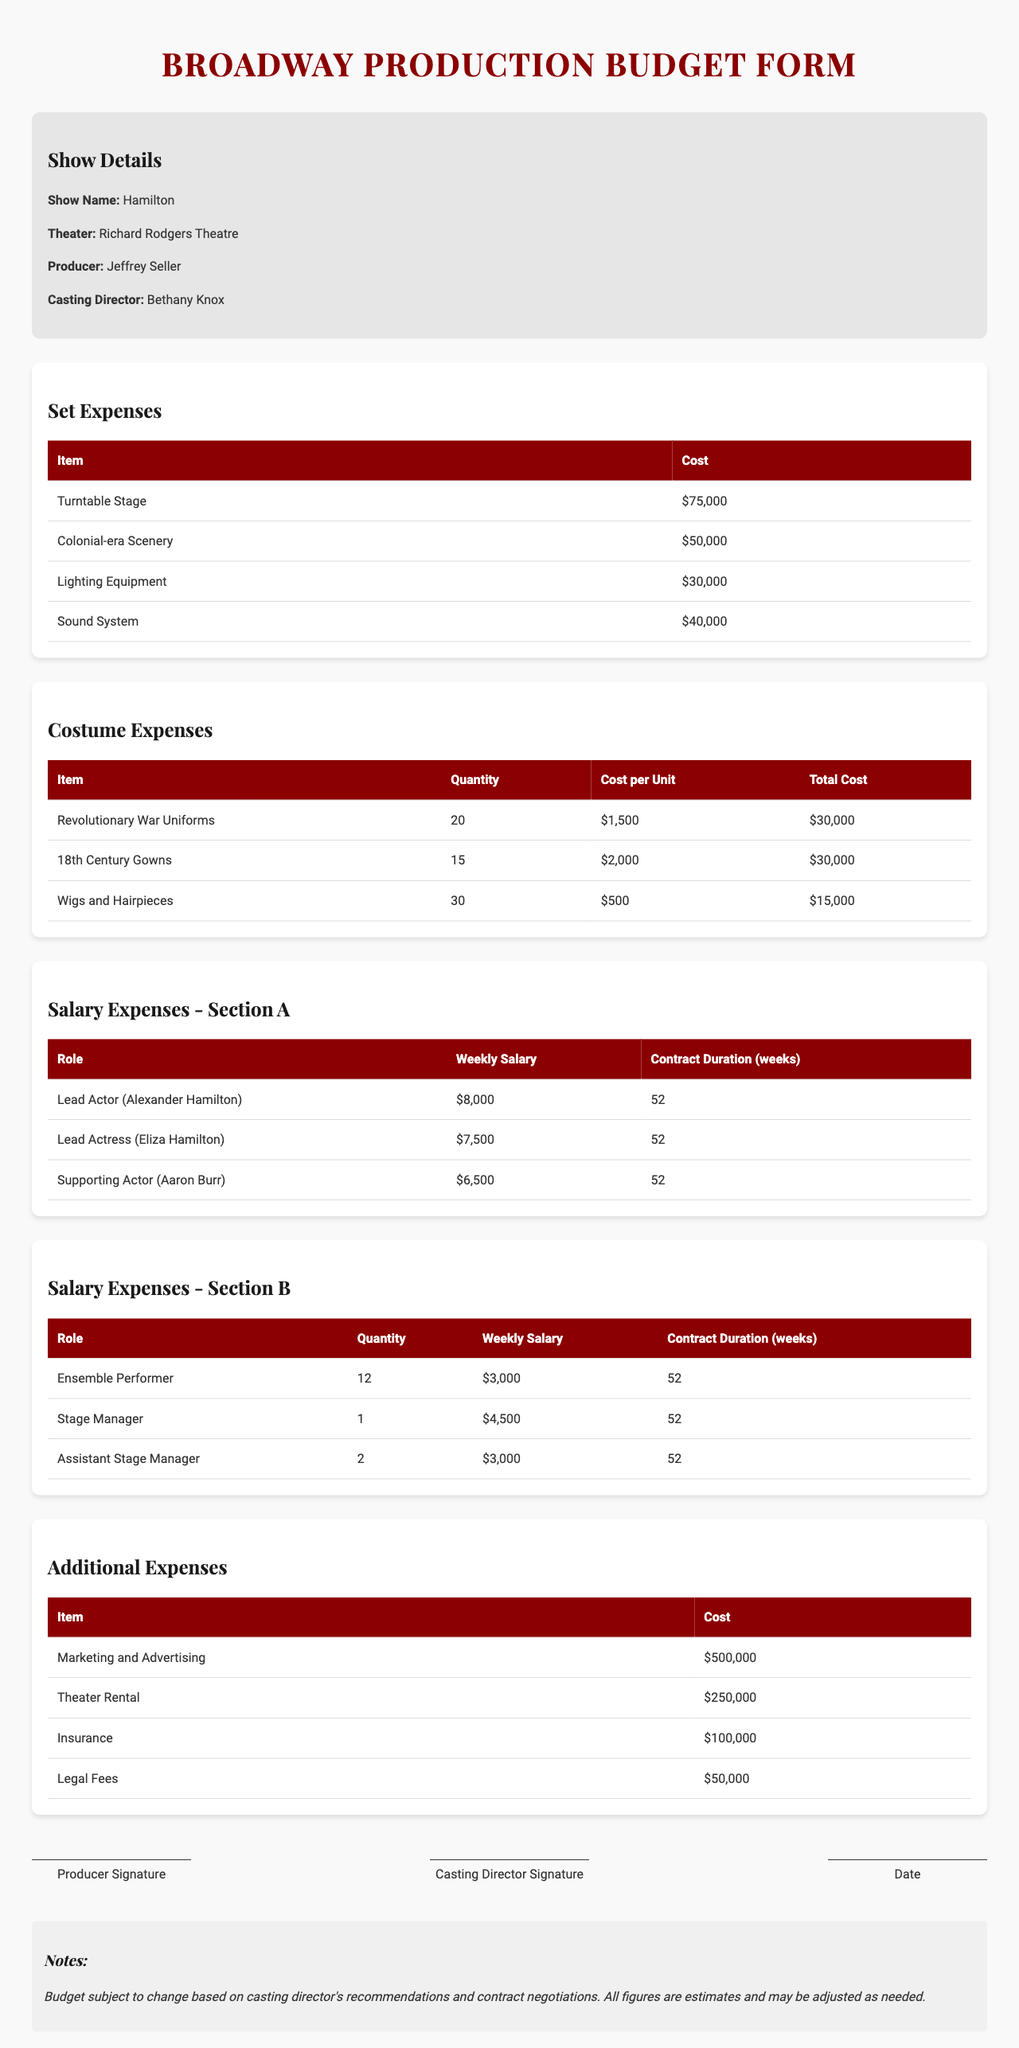What is the total cost of set expenses? The total cost of set expenses is calculated by adding the costs of all individual items listed under set expenses: $75000 + $50000 + $30000 + $40000 = $195000.
Answer: $195000 How many 18th Century Gowns are there? The number of 18th Century Gowns is specified in the costume expenses section, where it is indicated as 15.
Answer: 15 What is the weekly salary of the Lead Actress? The weekly salary is provided in the salary section, specifically listing it as $7500.
Answer: $7500 Which role has the highest weekly salary? By comparing the weekly salaries of each role, it is observed that the Lead Actor's salary of $8000 is the highest.
Answer: Lead Actor What is the total number of ensemble performers? The number of ensemble performers is stated as 12 in the salary expenses section.
Answer: 12 What is the total cost for Revolutionary War Uniforms? The total cost is listed in the costume expenses, stated as $30000 for 20 units at $1500 each.
Answer: $30000 What is mentioned in the notes section? The notes section states that the budget is subject to change based on casting director’s recommendations and contract negotiations, with all figures being estimates.
Answer: Budget subject to change What is the total cost for Marketing and Advertising? The total cost for Marketing and Advertising is explicitly listed as $500000 in the additional expenses section.
Answer: $500000 Who is the casting director for this show? The casting director's name is provided in the show details section, specifically as Bethany Knox.
Answer: Bethany Knox 